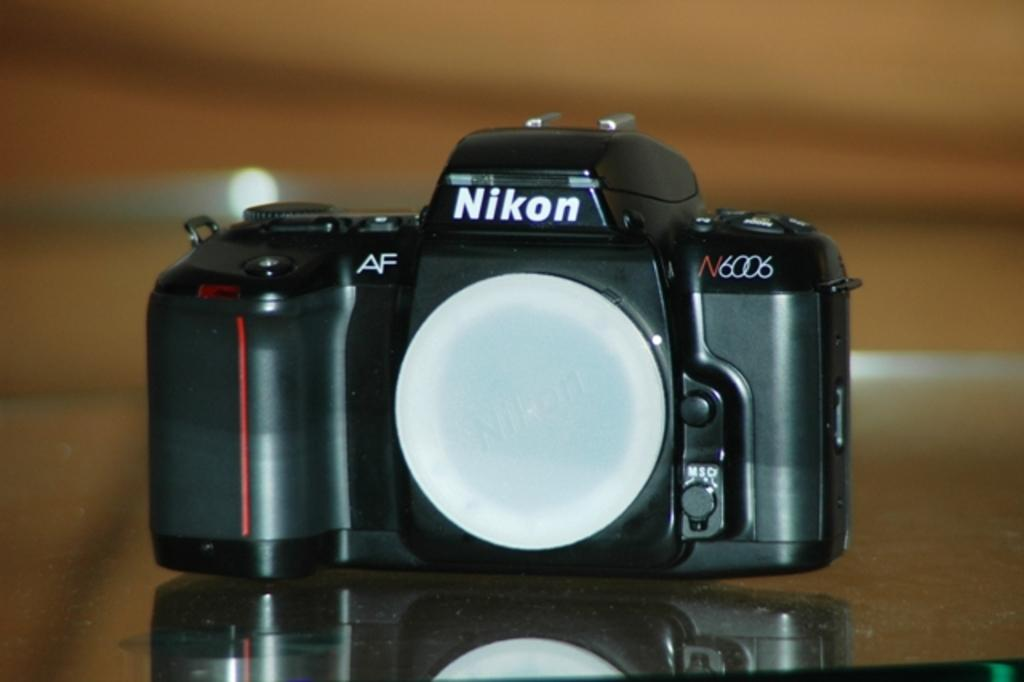Provide a one-sentence caption for the provided image. An old fashioned camera with the word Nikon on it. 